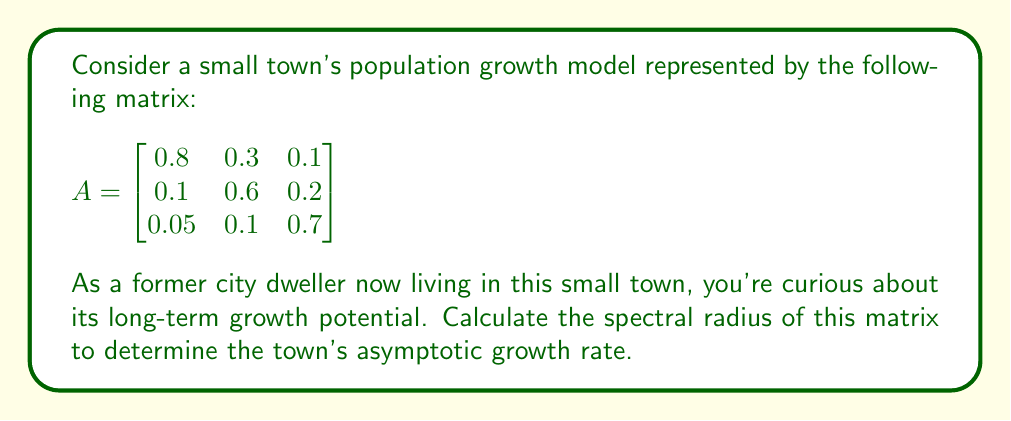Help me with this question. To find the spectral radius of matrix A, we need to follow these steps:

1) First, calculate the characteristic polynomial of A:
   $$det(A - \lambda I) = \begin{vmatrix}
   0.8 - \lambda & 0.3 & 0.1 \\
   0.1 & 0.6 - \lambda & 0.2 \\
   0.05 & 0.1 & 0.7 - \lambda
   \end{vmatrix}$$

2) Expand the determinant:
   $$(0.8 - \lambda)[(0.6 - \lambda)(0.7 - \lambda) - 0.02] - 0.3[0.1(0.7 - \lambda) - 0.01] + 0.1[0.1(0.6 - \lambda) - 0.02]$$

3) Simplify:
   $$-\lambda^3 + 2.1\lambda^2 - 1.33\lambda + 0.252 = 0$$

4) The roots of this polynomial are the eigenvalues of A. We can use a numerical method to find them:
   $\lambda_1 \approx 1.0416$
   $\lambda_2 \approx 0.5792$
   $\lambda_3 \approx 0.4792$

5) The spectral radius is the largest absolute value among these eigenvalues:
   $$\rho(A) = \max(|\lambda_1|, |\lambda_2|, |\lambda_3|) = |\lambda_1| \approx 1.0416$$

This value being slightly greater than 1 indicates that the town's population is expected to grow slowly over time.
Answer: $\rho(A) \approx 1.0416$ 